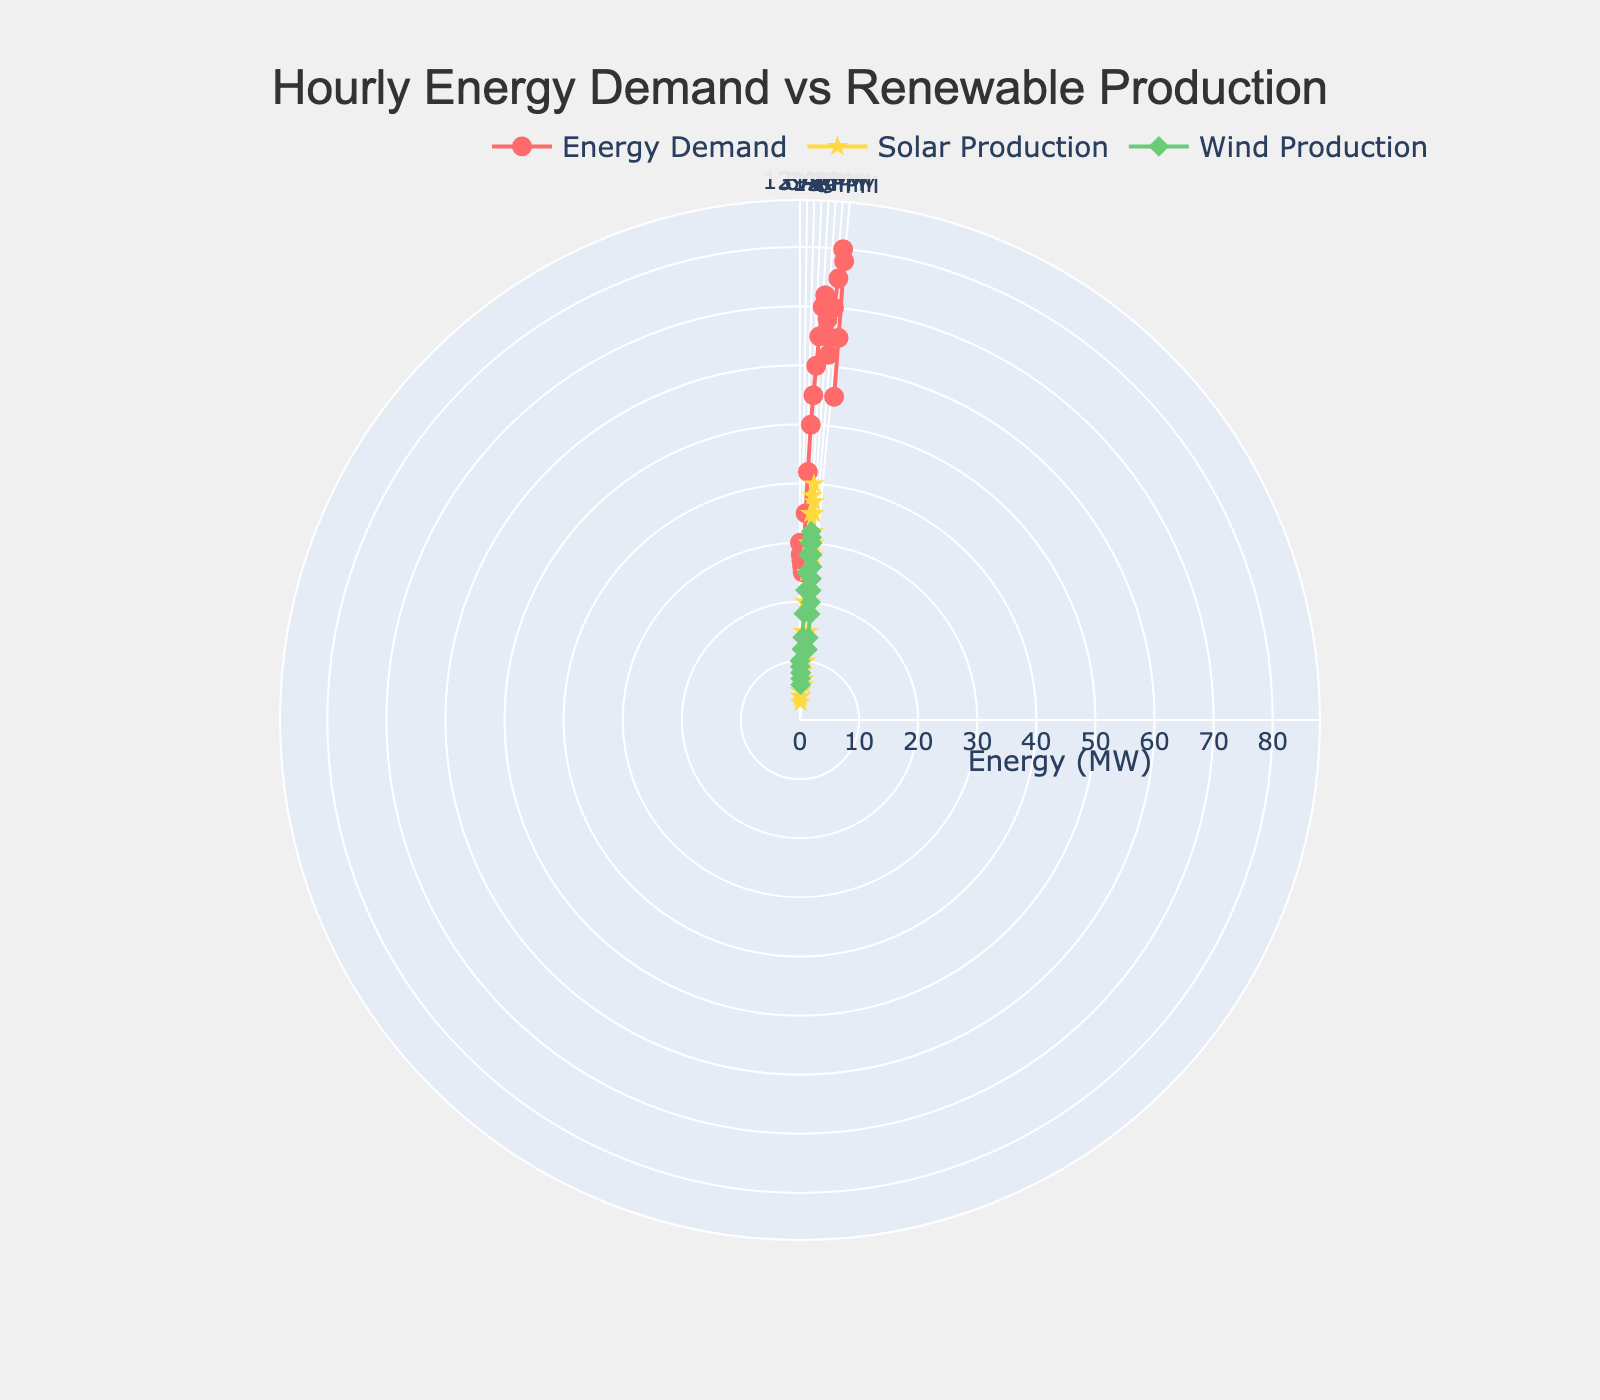What's the title of the figure? The title is usually at the top of the figure and describes the content of the plot. By looking at the plot, you can read the title directly from your screen.
Answer: Hourly Energy Demand vs Renewable Production How many distinct energy types are plotted on the figure? The figure uses different colors and markers to distinguish between different energy types. You can identify three distinct traces labeled as 'Energy Demand', 'Solar Production', and 'Wind Production'.
Answer: 3 At what hour is the energy demand at its peak? You can trace the marker for energy demand around the plot and identify the highest point. The demand peaks at the hour corresponding to the maximum radial distance from the center. The highest radial point falls at the 20th hour.
Answer: 20th hour How does the solar production compare to wind production at 3 PM? From the angular axis tick labels, you locate 3 PM (which corresponds to the angle for 15th hour). Then, trace the markers for 'Solar Production' (star) and 'Wind Production' (diamond) at this hour to compare their radial distances. Solar production is slightly higher than wind production at 3 PM.
Answer: Solar > Wind Which energy type shows the most significant hourly fluctuations? Look at the markers and lines for each energy type. The energy type with the largest changes in radial distance between consecutive points has the most significant fluctuations. 'Energy Demand' shows large fluctuations compared to solar and wind production.
Answer: Energy Demand What is the general trend of solar production throughout the day? Observing the 'Solar Production' trace, note how the radial distances change from hour to hour. Solar production increases from morning, peaks around midday, and then decreases towards the evening.
Answer: Increases then decreases Does wind production ever exceed solar production during the day? By following the radial distances of 'Wind Production' and 'Solar Production' markers throughout the plot, you can identify if there is any point where wind production is greater than solar production. Wind production does not exceed solar production at any point.
Answer: No What's the combined energy production (solar + wind) at noon? Locate noon on the angular axis (12th hour), then sum the radial distances for 'Solar Production' (star marker) and 'Wind Production' (diamond marker). Solar production is 38 MW and wind production is 30 MW, so the total is 68 MW.
Answer: 68 MW By how many MW does energy demand increase from 6 AM to 9 AM? Identify the radial distances for 'Energy Demand' at 6 AM (35 MW) and 9 AM (55 MW), then subtract the former from the latter to find the increase. The increase in energy demand is 55 - 35 = 20 MW.
Answer: 20 MW What hour experiences the lowest wind production? Trace the 'Wind Production' markers to find the smallest radial distance from the center. This occurs at the 4th hour with wind production at 6 MW.
Answer: 4th hour 